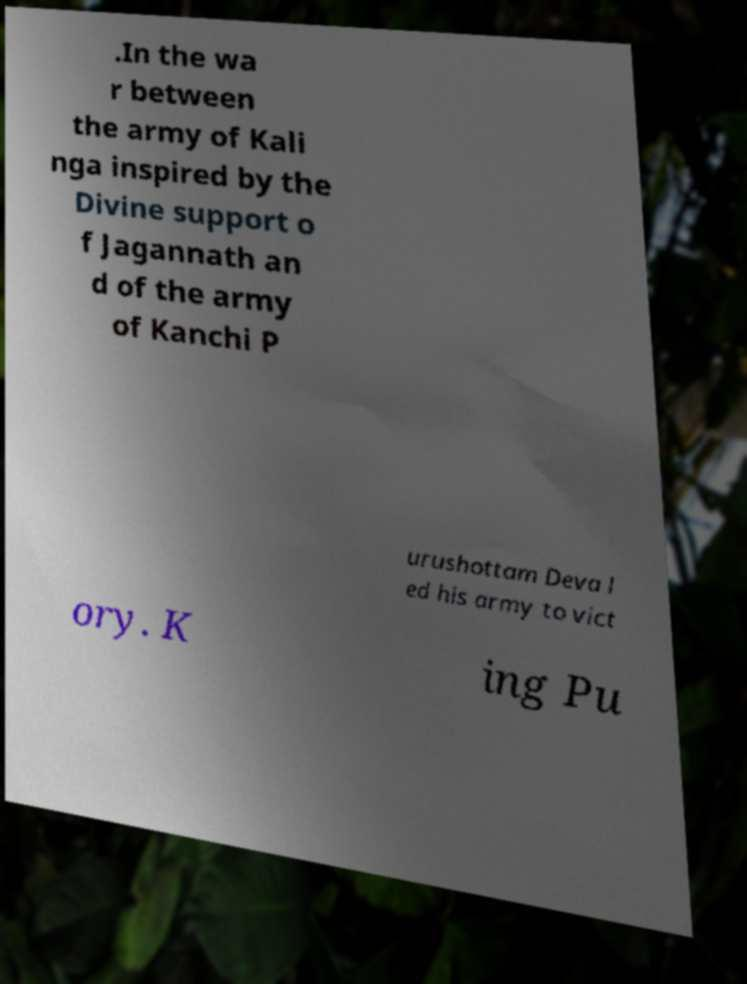There's text embedded in this image that I need extracted. Can you transcribe it verbatim? .In the wa r between the army of Kali nga inspired by the Divine support o f Jagannath an d of the army of Kanchi P urushottam Deva l ed his army to vict ory. K ing Pu 